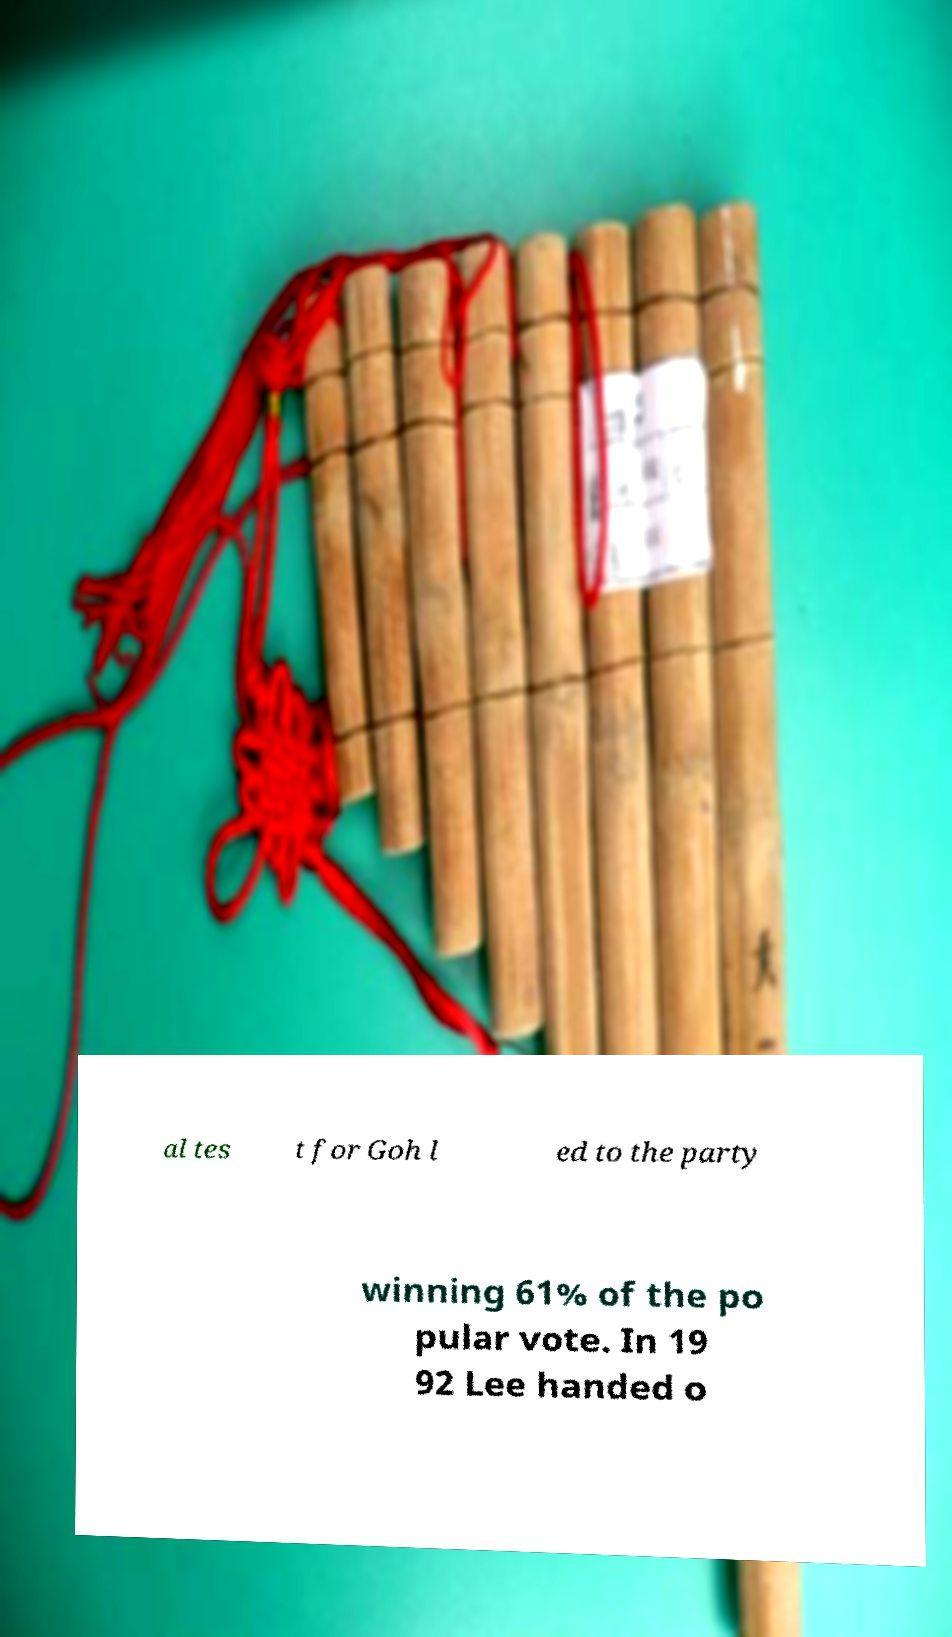Please read and relay the text visible in this image. What does it say? al tes t for Goh l ed to the party winning 61% of the po pular vote. In 19 92 Lee handed o 